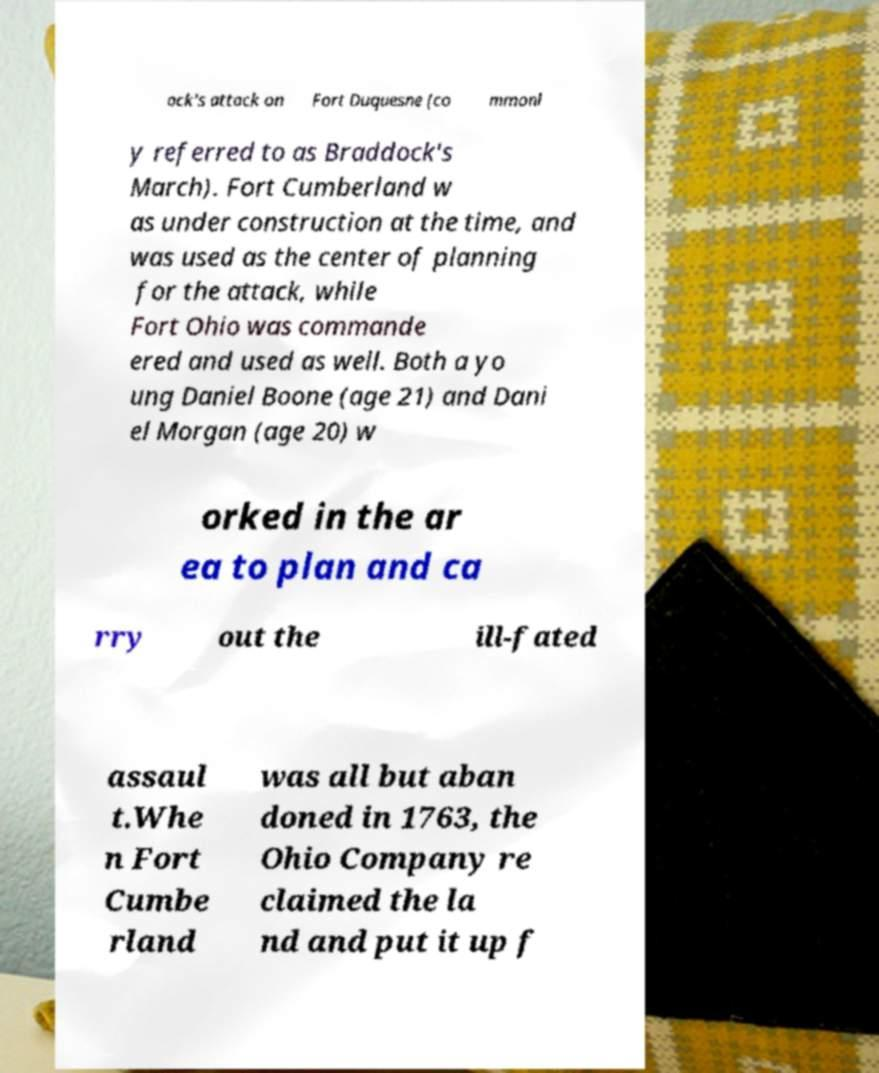Please identify and transcribe the text found in this image. ock's attack on Fort Duquesne (co mmonl y referred to as Braddock's March). Fort Cumberland w as under construction at the time, and was used as the center of planning for the attack, while Fort Ohio was commande ered and used as well. Both a yo ung Daniel Boone (age 21) and Dani el Morgan (age 20) w orked in the ar ea to plan and ca rry out the ill-fated assaul t.Whe n Fort Cumbe rland was all but aban doned in 1763, the Ohio Company re claimed the la nd and put it up f 